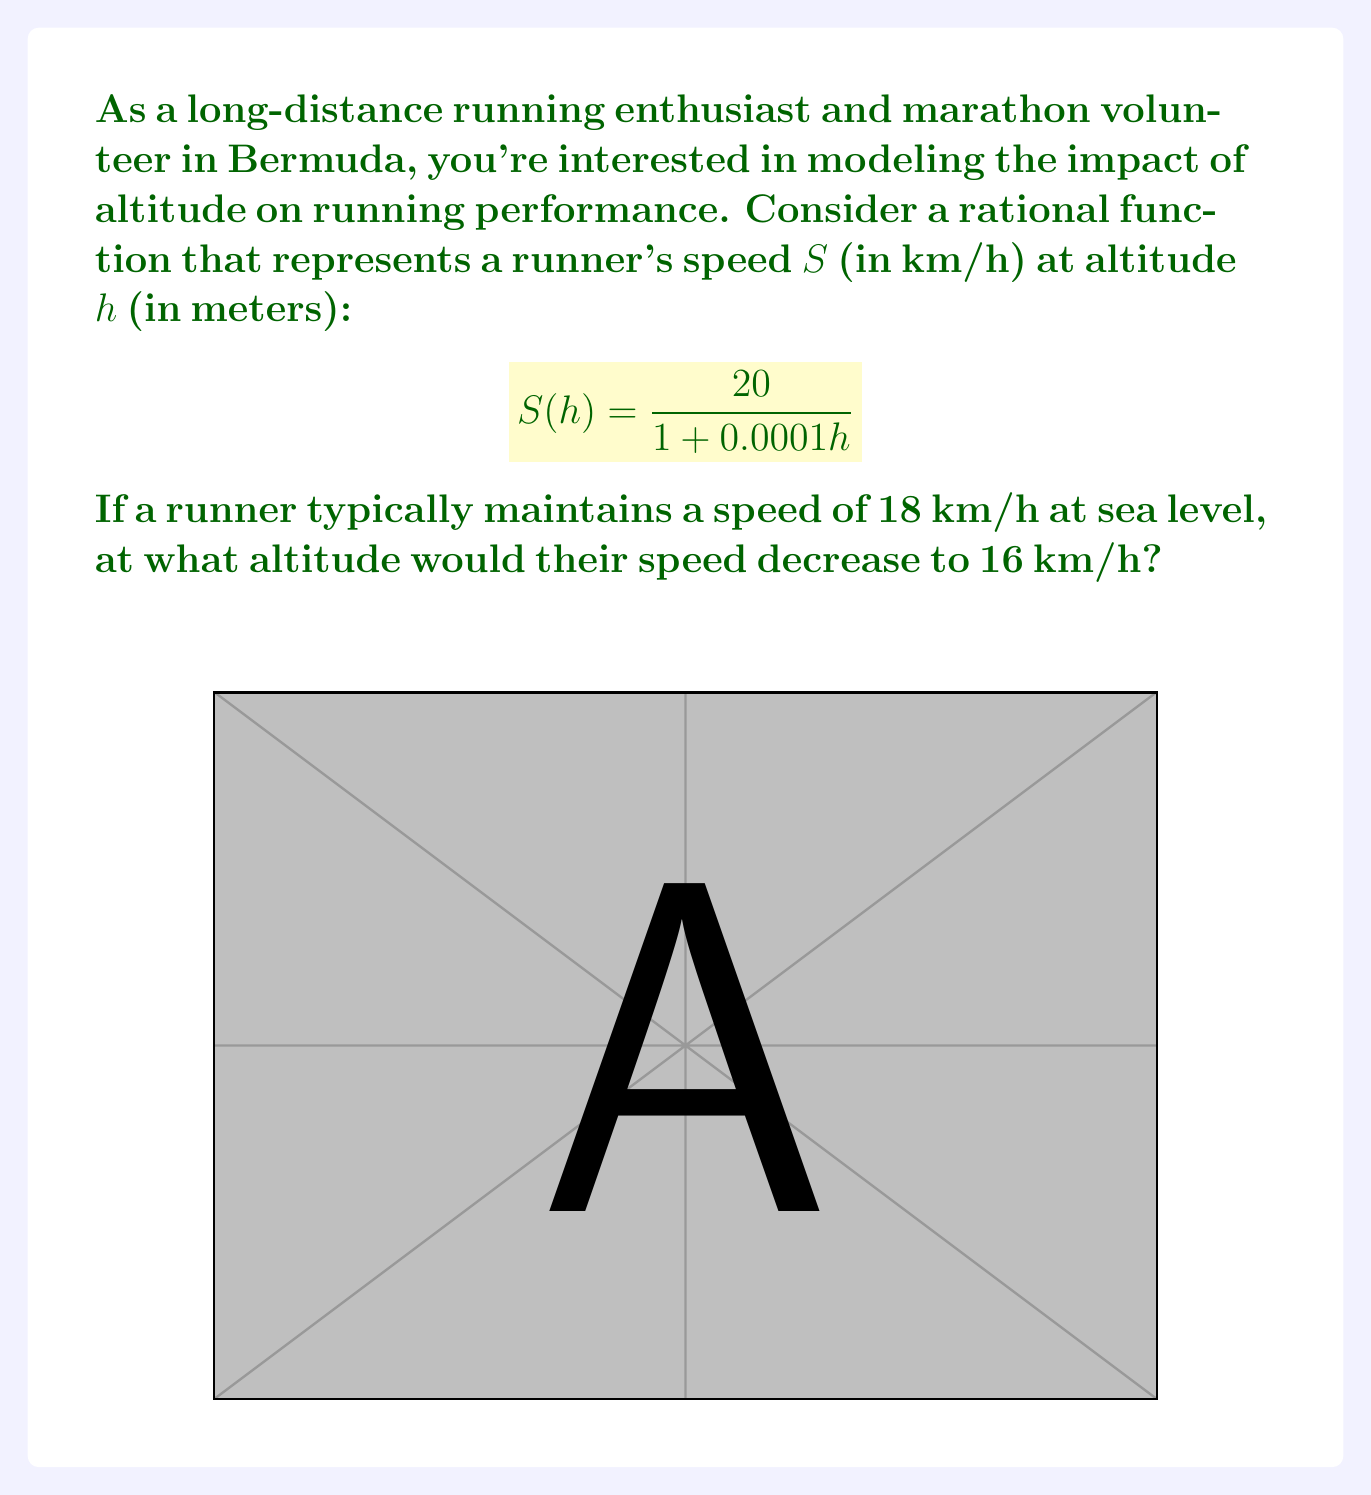Help me with this question. Let's approach this step-by-step:

1) First, we need to set up an equation using the given rational function:

   $$\frac{20}{1 + 0.0001h} = 16$$

2) Now, let's solve this equation for h:
   
   Multiply both sides by $(1 + 0.0001h)$:
   $$20 = 16(1 + 0.0001h)$$

3) Expand the right side:
   $$20 = 16 + 0.0016h$$

4) Subtract 16 from both sides:
   $$4 = 0.0016h$$

5) Divide both sides by 0.0016:
   $$\frac{4}{0.0016} = h$$

6) Simplify:
   $$2500 = h$$

Therefore, the runner's speed would decrease to 16 km/h at an altitude of 2500 meters.

This makes sense in the context of long-distance running and marathon volunteering in Bermuda, as understanding the effects of altitude on performance is crucial for runners and organizers, especially when dealing with varied terrain or planning high-altitude events.
Answer: 2500 meters 